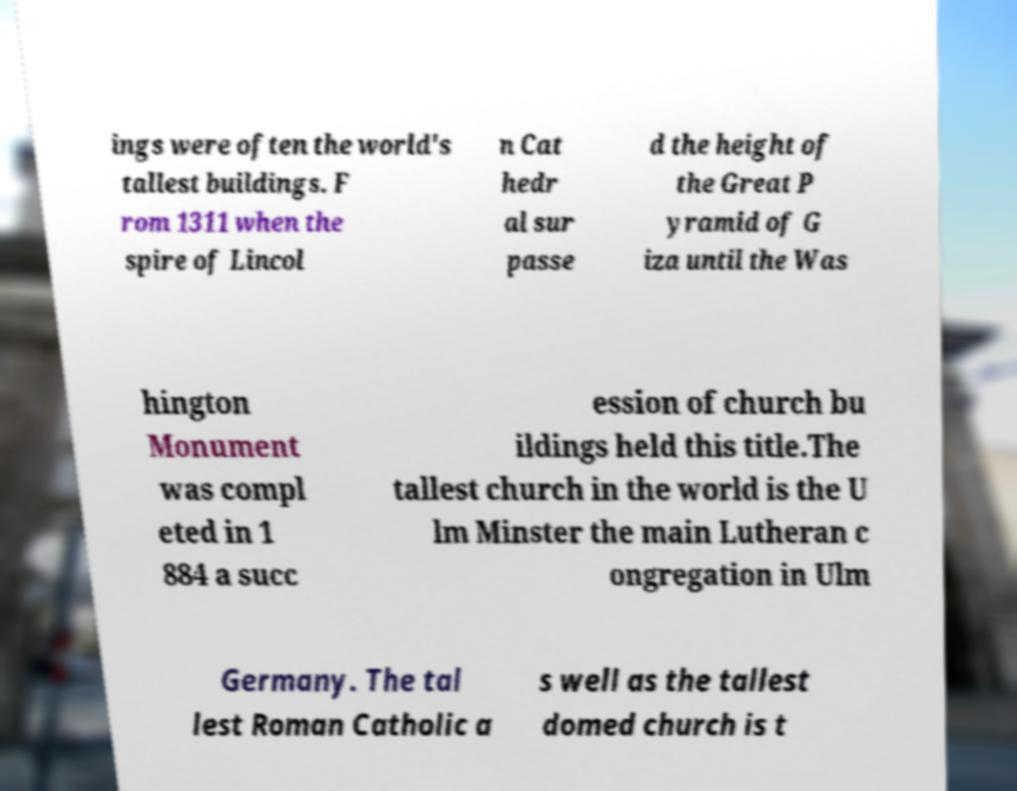What messages or text are displayed in this image? I need them in a readable, typed format. ings were often the world's tallest buildings. F rom 1311 when the spire of Lincol n Cat hedr al sur passe d the height of the Great P yramid of G iza until the Was hington Monument was compl eted in 1 884 a succ ession of church bu ildings held this title.The tallest church in the world is the U lm Minster the main Lutheran c ongregation in Ulm Germany. The tal lest Roman Catholic a s well as the tallest domed church is t 